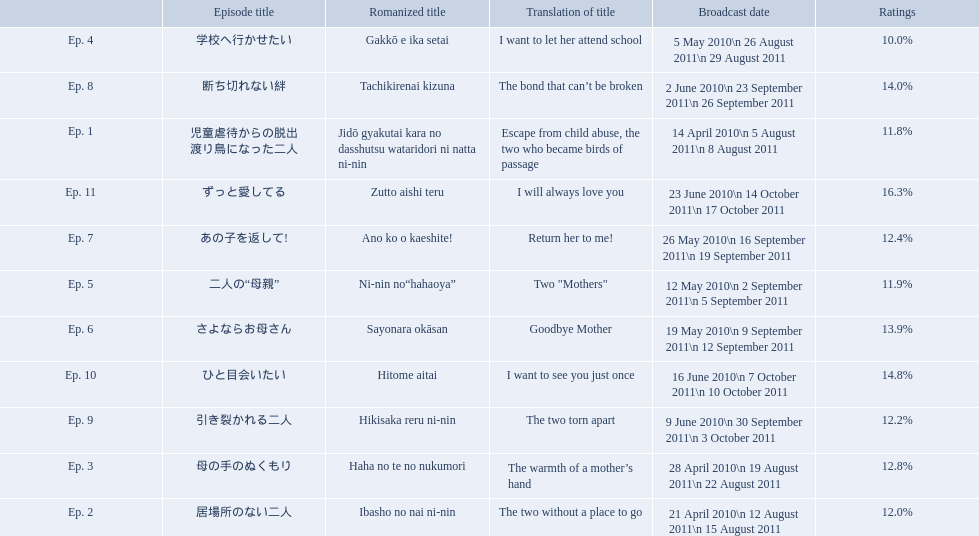Which episode had the highest ratings? Ep. 11. Which episode was named haha no te no nukumori? Ep. 3. Besides episode 10 which episode had a 14% rating? Ep. 8. What are the episode numbers? Ep. 1, Ep. 2, Ep. 3, Ep. 4, Ep. 5, Ep. 6, Ep. 7, Ep. 8, Ep. 9, Ep. 10, Ep. 11. What was the percentage of total ratings for episode 8? 14.0%. 